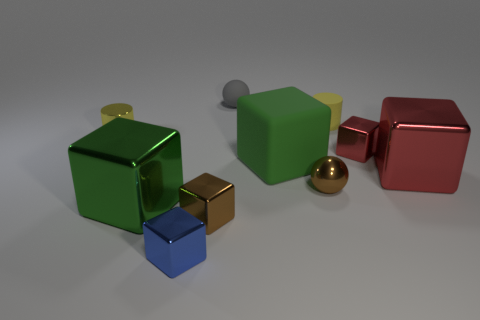Subtract all tiny blue blocks. How many blocks are left? 5 Subtract all red cubes. How many cubes are left? 4 Subtract all cylinders. How many objects are left? 8 Subtract 2 spheres. How many spheres are left? 0 Subtract all brown balls. Subtract all purple cubes. How many balls are left? 1 Subtract all purple balls. How many green cubes are left? 2 Subtract all large green matte blocks. Subtract all tiny yellow things. How many objects are left? 7 Add 4 red blocks. How many red blocks are left? 6 Add 9 small purple rubber things. How many small purple rubber things exist? 9 Subtract 2 green cubes. How many objects are left? 8 